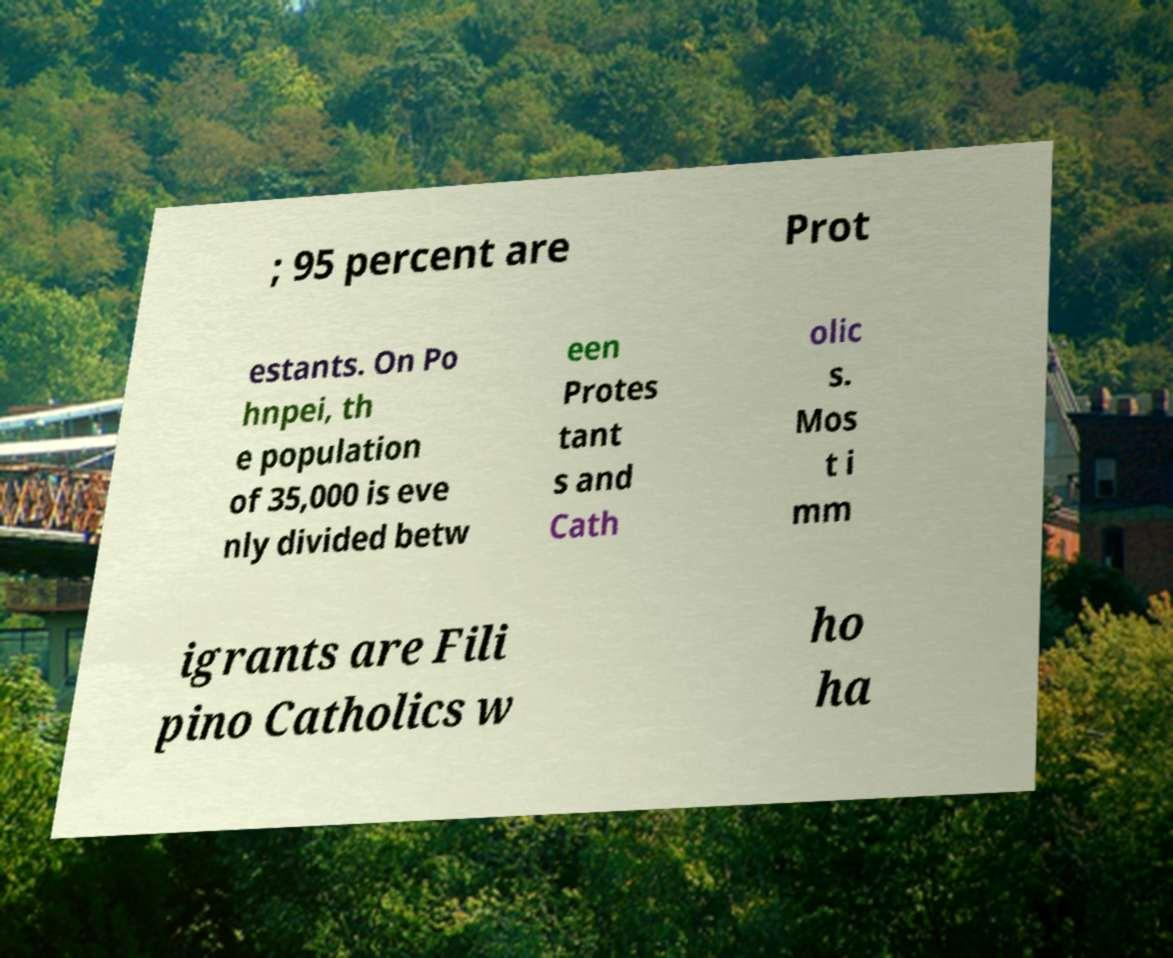Can you read and provide the text displayed in the image?This photo seems to have some interesting text. Can you extract and type it out for me? ; 95 percent are Prot estants. On Po hnpei, th e population of 35,000 is eve nly divided betw een Protes tant s and Cath olic s. Mos t i mm igrants are Fili pino Catholics w ho ha 